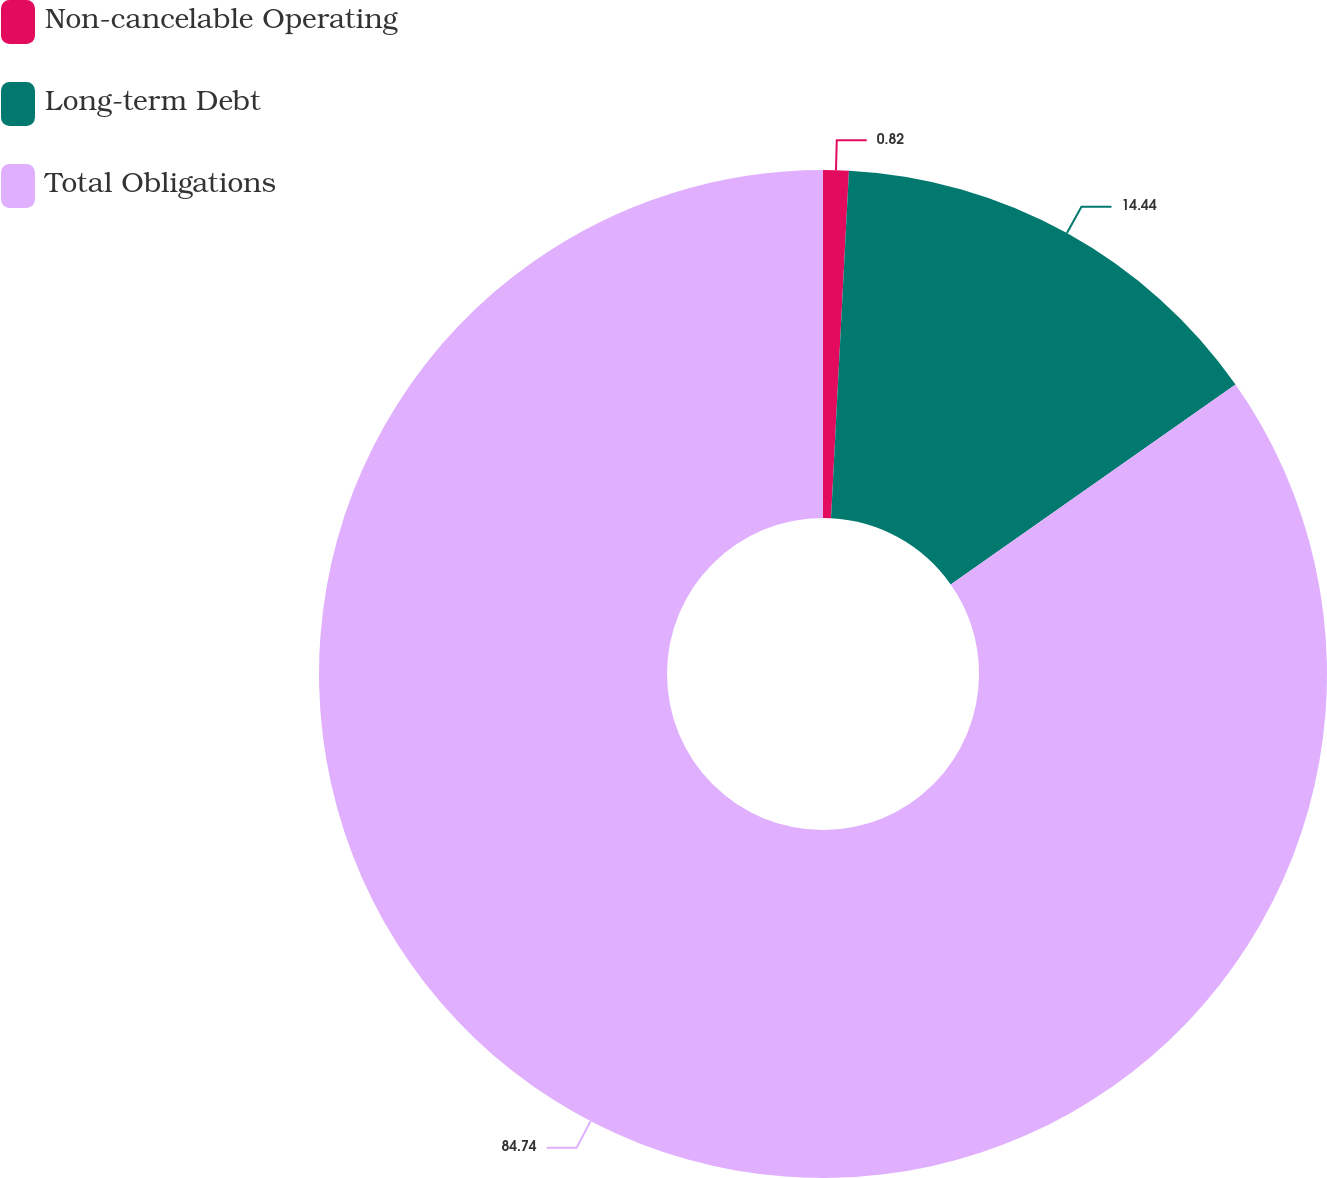Convert chart. <chart><loc_0><loc_0><loc_500><loc_500><pie_chart><fcel>Non-cancelable Operating<fcel>Long-term Debt<fcel>Total Obligations<nl><fcel>0.82%<fcel>14.44%<fcel>84.73%<nl></chart> 